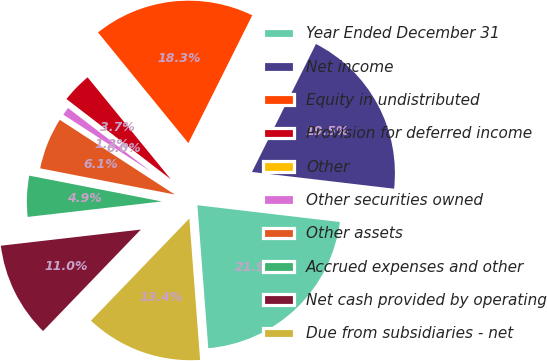Convert chart to OTSL. <chart><loc_0><loc_0><loc_500><loc_500><pie_chart><fcel>Year Ended December 31<fcel>Net income<fcel>Equity in undistributed<fcel>Provision for deferred income<fcel>Other<fcel>Other securities owned<fcel>Other assets<fcel>Accrued expenses and other<fcel>Net cash provided by operating<fcel>Due from subsidiaries - net<nl><fcel>21.92%<fcel>19.49%<fcel>18.27%<fcel>3.67%<fcel>0.02%<fcel>1.24%<fcel>6.11%<fcel>4.89%<fcel>10.97%<fcel>13.41%<nl></chart> 